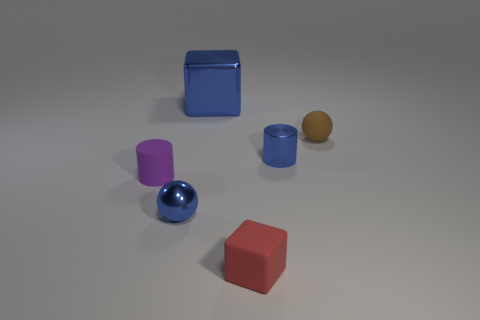Are there any other things that are the same size as the blue cube?
Keep it short and to the point. No. What is the color of the tiny cube?
Your answer should be compact. Red. The block in front of the small purple rubber object is what color?
Your response must be concise. Red. What number of red cubes are on the left side of the block in front of the big blue cube?
Provide a succinct answer. 0. There is a purple matte cylinder; is it the same size as the metal thing that is to the right of the tiny red thing?
Keep it short and to the point. Yes. Is there a brown cylinder that has the same size as the brown ball?
Make the answer very short. No. What number of objects are either big gray shiny cubes or small red cubes?
Give a very brief answer. 1. Does the cube that is behind the purple rubber cylinder have the same size as the blue object that is left of the large thing?
Ensure brevity in your answer.  No. Are there any purple matte things that have the same shape as the small brown object?
Give a very brief answer. No. Are there fewer small purple things that are behind the purple matte cylinder than things?
Ensure brevity in your answer.  Yes. 